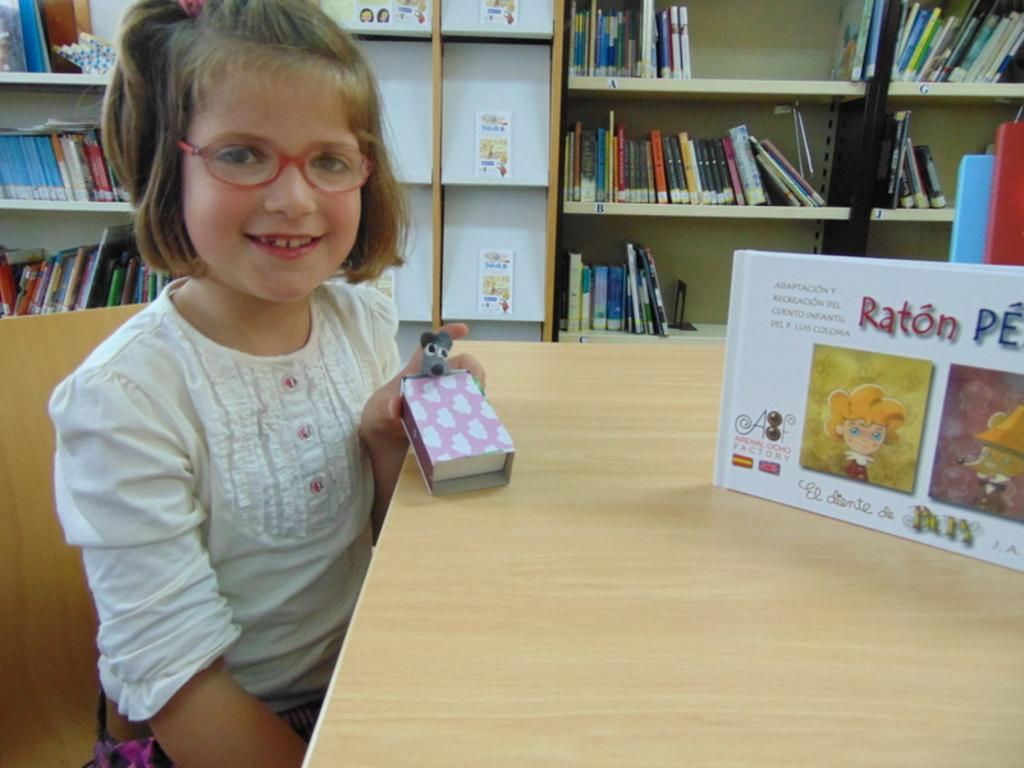<image>
Give a short and clear explanation of the subsequent image. girl sitting at table holding pink and white box and a display for raton close 